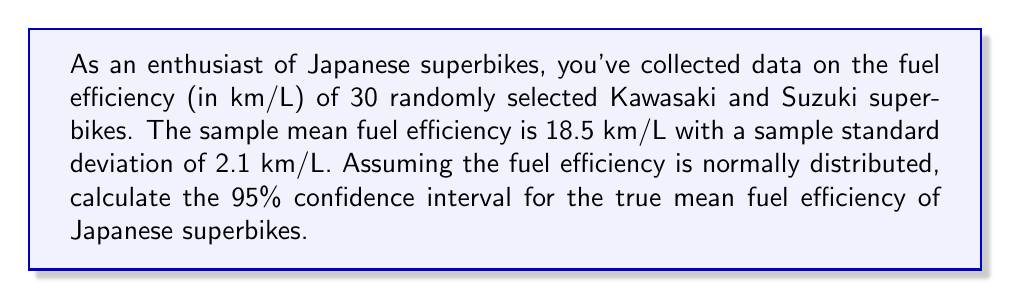Give your solution to this math problem. To determine the confidence interval for the mean fuel efficiency, we'll use the formula:

$$ \text{CI} = \bar{x} \pm t_{\alpha/2} \cdot \frac{s}{\sqrt{n}} $$

Where:
- $\bar{x}$ is the sample mean (18.5 km/L)
- $s$ is the sample standard deviation (2.1 km/L)
- $n$ is the sample size (30)
- $t_{\alpha/2}$ is the t-value for a 95% confidence interval with 29 degrees of freedom

Steps:
1) Find $t_{\alpha/2}$:
   For a 95% CI with 29 df, $t_{\alpha/2} = 2.045$ (from t-distribution table)

2) Calculate the margin of error:
   $$ \text{ME} = t_{\alpha/2} \cdot \frac{s}{\sqrt{n}} = 2.045 \cdot \frac{2.1}{\sqrt{30}} = 0.7845 $$

3) Calculate the lower and upper bounds of the CI:
   $$ \text{Lower bound} = 18.5 - 0.7845 = 17.7155 $$
   $$ \text{Upper bound} = 18.5 + 0.7845 = 19.2845 $$

4) Round to two decimal places for practical interpretation.
Answer: The 95% confidence interval for the mean fuel efficiency of Japanese superbikes is (17.72 km/L, 19.28 km/L). 